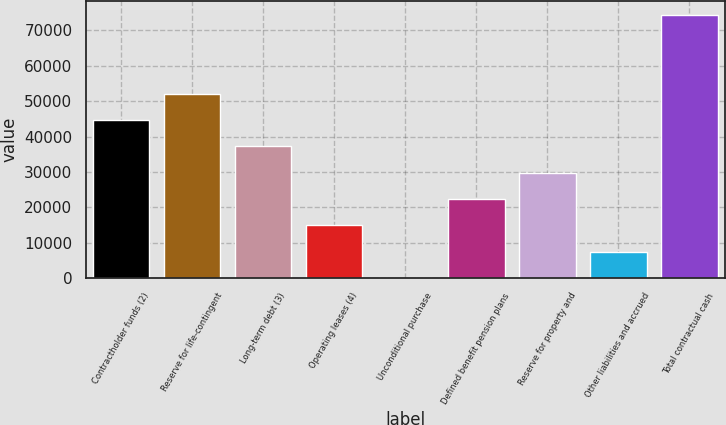Convert chart to OTSL. <chart><loc_0><loc_0><loc_500><loc_500><bar_chart><fcel>Contractholder funds (2)<fcel>Reserve for life-contingent<fcel>Long-term debt (3)<fcel>Operating leases (4)<fcel>Unconditional purchase<fcel>Defined benefit pension plans<fcel>Reserve for property and<fcel>Other liabilities and accrued<fcel>Total contractual cash<nl><fcel>44704.6<fcel>52155.2<fcel>37254<fcel>14902.2<fcel>1<fcel>22352.8<fcel>29803.4<fcel>7451.6<fcel>74507<nl></chart> 